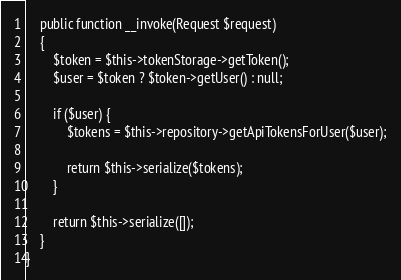<code> <loc_0><loc_0><loc_500><loc_500><_PHP_>
    public function __invoke(Request $request)
    {
        $token = $this->tokenStorage->getToken();
        $user = $token ? $token->getUser() : null;

        if ($user) {
            $tokens = $this->repository->getApiTokensForUser($user);

            return $this->serialize($tokens);
        }

        return $this->serialize([]);
    }
}
</code> 